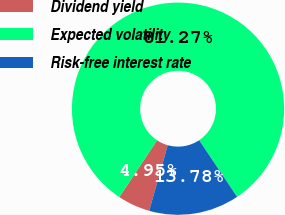Convert chart to OTSL. <chart><loc_0><loc_0><loc_500><loc_500><pie_chart><fcel>Dividend yield<fcel>Expected volatility<fcel>Risk-free interest rate<nl><fcel>4.95%<fcel>81.27%<fcel>13.78%<nl></chart> 